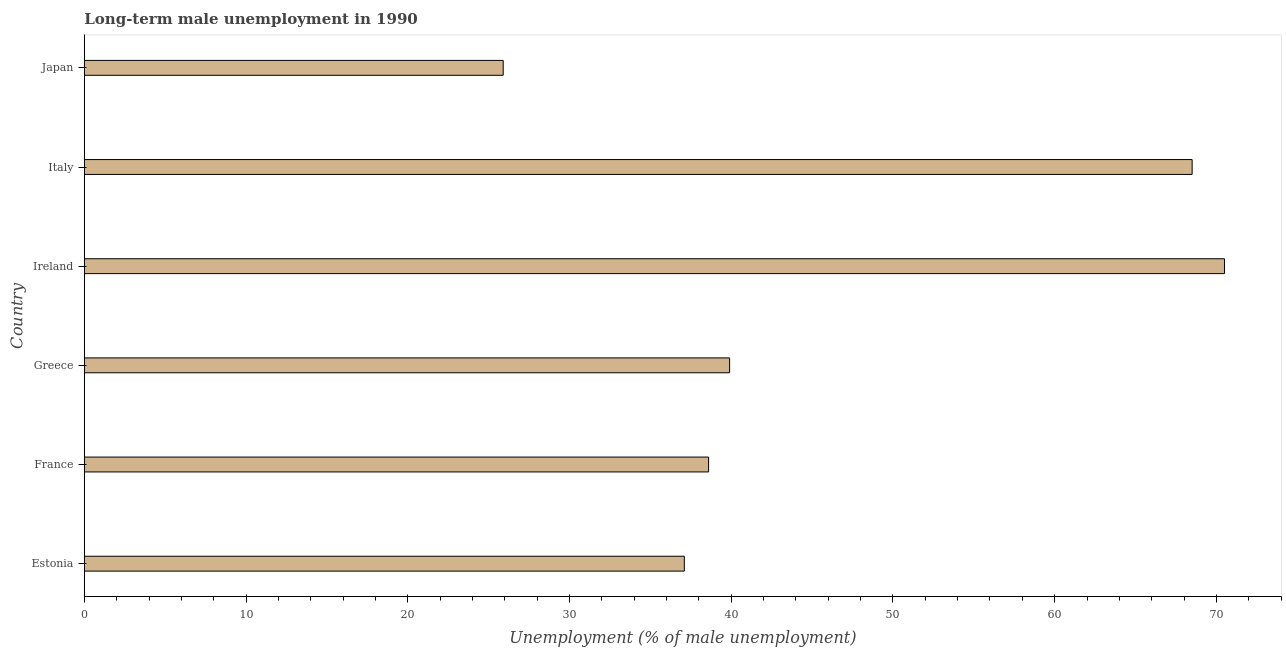Does the graph contain any zero values?
Your answer should be very brief. No. What is the title of the graph?
Keep it short and to the point. Long-term male unemployment in 1990. What is the label or title of the X-axis?
Your answer should be compact. Unemployment (% of male unemployment). What is the long-term male unemployment in Ireland?
Your answer should be very brief. 70.5. Across all countries, what is the maximum long-term male unemployment?
Make the answer very short. 70.5. Across all countries, what is the minimum long-term male unemployment?
Offer a terse response. 25.9. In which country was the long-term male unemployment maximum?
Provide a succinct answer. Ireland. What is the sum of the long-term male unemployment?
Provide a succinct answer. 280.5. What is the difference between the long-term male unemployment in Ireland and Italy?
Your answer should be compact. 2. What is the average long-term male unemployment per country?
Keep it short and to the point. 46.75. What is the median long-term male unemployment?
Offer a very short reply. 39.25. What is the ratio of the long-term male unemployment in Estonia to that in Japan?
Provide a succinct answer. 1.43. Is the difference between the long-term male unemployment in Greece and Italy greater than the difference between any two countries?
Provide a short and direct response. No. What is the difference between the highest and the lowest long-term male unemployment?
Provide a succinct answer. 44.6. Are the values on the major ticks of X-axis written in scientific E-notation?
Make the answer very short. No. What is the Unemployment (% of male unemployment) of Estonia?
Your response must be concise. 37.1. What is the Unemployment (% of male unemployment) in France?
Ensure brevity in your answer.  38.6. What is the Unemployment (% of male unemployment) in Greece?
Ensure brevity in your answer.  39.9. What is the Unemployment (% of male unemployment) of Ireland?
Keep it short and to the point. 70.5. What is the Unemployment (% of male unemployment) of Italy?
Offer a very short reply. 68.5. What is the Unemployment (% of male unemployment) in Japan?
Give a very brief answer. 25.9. What is the difference between the Unemployment (% of male unemployment) in Estonia and France?
Give a very brief answer. -1.5. What is the difference between the Unemployment (% of male unemployment) in Estonia and Ireland?
Give a very brief answer. -33.4. What is the difference between the Unemployment (% of male unemployment) in Estonia and Italy?
Offer a very short reply. -31.4. What is the difference between the Unemployment (% of male unemployment) in Estonia and Japan?
Your answer should be compact. 11.2. What is the difference between the Unemployment (% of male unemployment) in France and Greece?
Ensure brevity in your answer.  -1.3. What is the difference between the Unemployment (% of male unemployment) in France and Ireland?
Provide a succinct answer. -31.9. What is the difference between the Unemployment (% of male unemployment) in France and Italy?
Give a very brief answer. -29.9. What is the difference between the Unemployment (% of male unemployment) in Greece and Ireland?
Make the answer very short. -30.6. What is the difference between the Unemployment (% of male unemployment) in Greece and Italy?
Offer a terse response. -28.6. What is the difference between the Unemployment (% of male unemployment) in Ireland and Japan?
Offer a terse response. 44.6. What is the difference between the Unemployment (% of male unemployment) in Italy and Japan?
Provide a succinct answer. 42.6. What is the ratio of the Unemployment (% of male unemployment) in Estonia to that in Greece?
Make the answer very short. 0.93. What is the ratio of the Unemployment (% of male unemployment) in Estonia to that in Ireland?
Offer a terse response. 0.53. What is the ratio of the Unemployment (% of male unemployment) in Estonia to that in Italy?
Provide a succinct answer. 0.54. What is the ratio of the Unemployment (% of male unemployment) in Estonia to that in Japan?
Your answer should be compact. 1.43. What is the ratio of the Unemployment (% of male unemployment) in France to that in Greece?
Give a very brief answer. 0.97. What is the ratio of the Unemployment (% of male unemployment) in France to that in Ireland?
Ensure brevity in your answer.  0.55. What is the ratio of the Unemployment (% of male unemployment) in France to that in Italy?
Provide a succinct answer. 0.56. What is the ratio of the Unemployment (% of male unemployment) in France to that in Japan?
Your answer should be compact. 1.49. What is the ratio of the Unemployment (% of male unemployment) in Greece to that in Ireland?
Make the answer very short. 0.57. What is the ratio of the Unemployment (% of male unemployment) in Greece to that in Italy?
Provide a succinct answer. 0.58. What is the ratio of the Unemployment (% of male unemployment) in Greece to that in Japan?
Make the answer very short. 1.54. What is the ratio of the Unemployment (% of male unemployment) in Ireland to that in Italy?
Give a very brief answer. 1.03. What is the ratio of the Unemployment (% of male unemployment) in Ireland to that in Japan?
Provide a succinct answer. 2.72. What is the ratio of the Unemployment (% of male unemployment) in Italy to that in Japan?
Keep it short and to the point. 2.65. 